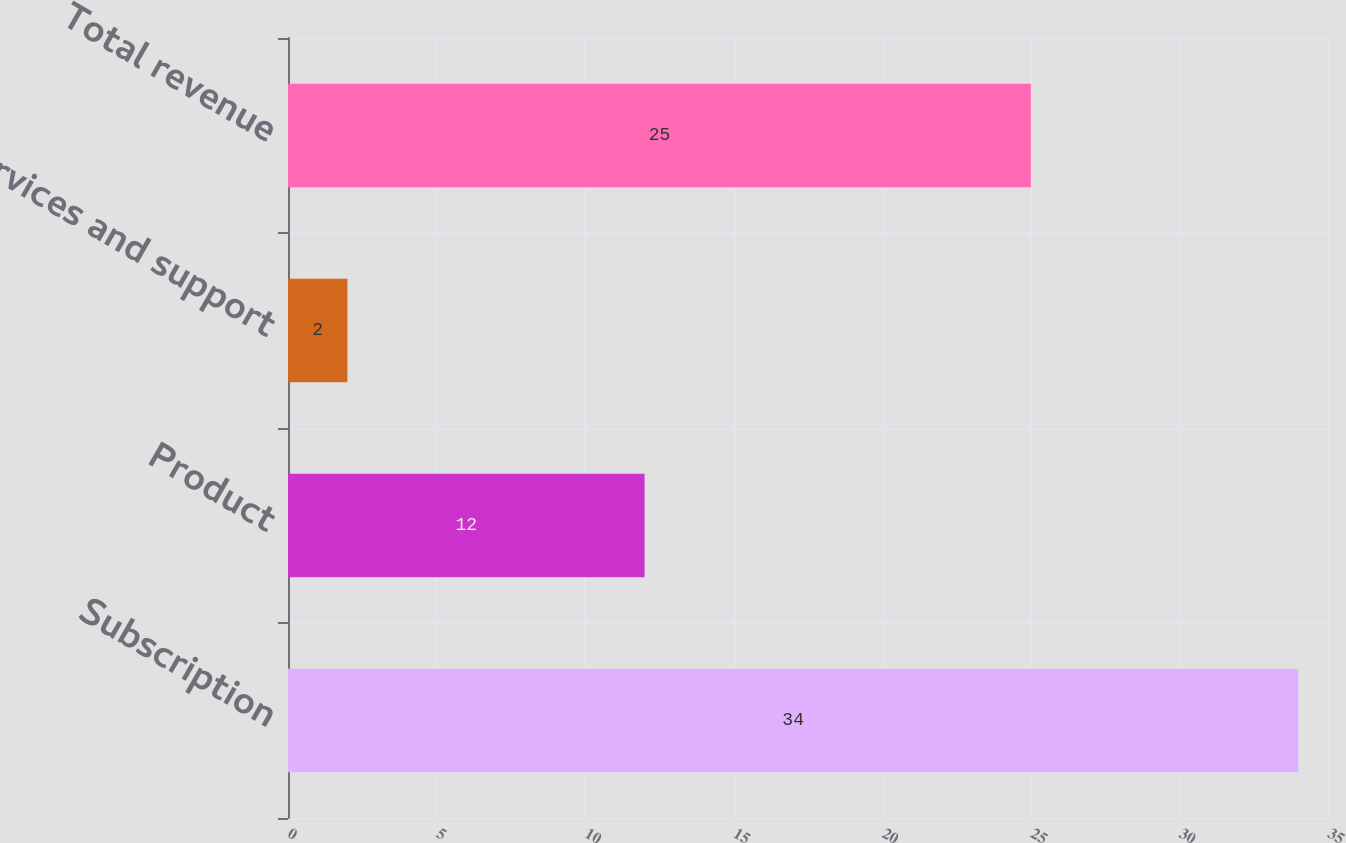Convert chart to OTSL. <chart><loc_0><loc_0><loc_500><loc_500><bar_chart><fcel>Subscription<fcel>Product<fcel>Services and support<fcel>Total revenue<nl><fcel>34<fcel>12<fcel>2<fcel>25<nl></chart> 